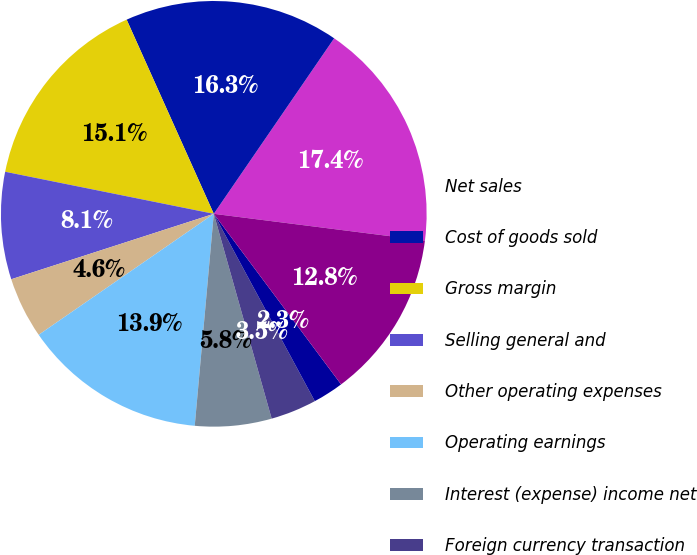Convert chart to OTSL. <chart><loc_0><loc_0><loc_500><loc_500><pie_chart><fcel>Net sales<fcel>Cost of goods sold<fcel>Gross margin<fcel>Selling general and<fcel>Other operating expenses<fcel>Operating earnings<fcel>Interest (expense) income net<fcel>Foreign currency transaction<fcel>Other expense<fcel>Earnings from consolidated<nl><fcel>17.44%<fcel>16.28%<fcel>15.12%<fcel>8.14%<fcel>4.65%<fcel>13.95%<fcel>5.81%<fcel>3.49%<fcel>2.33%<fcel>12.79%<nl></chart> 